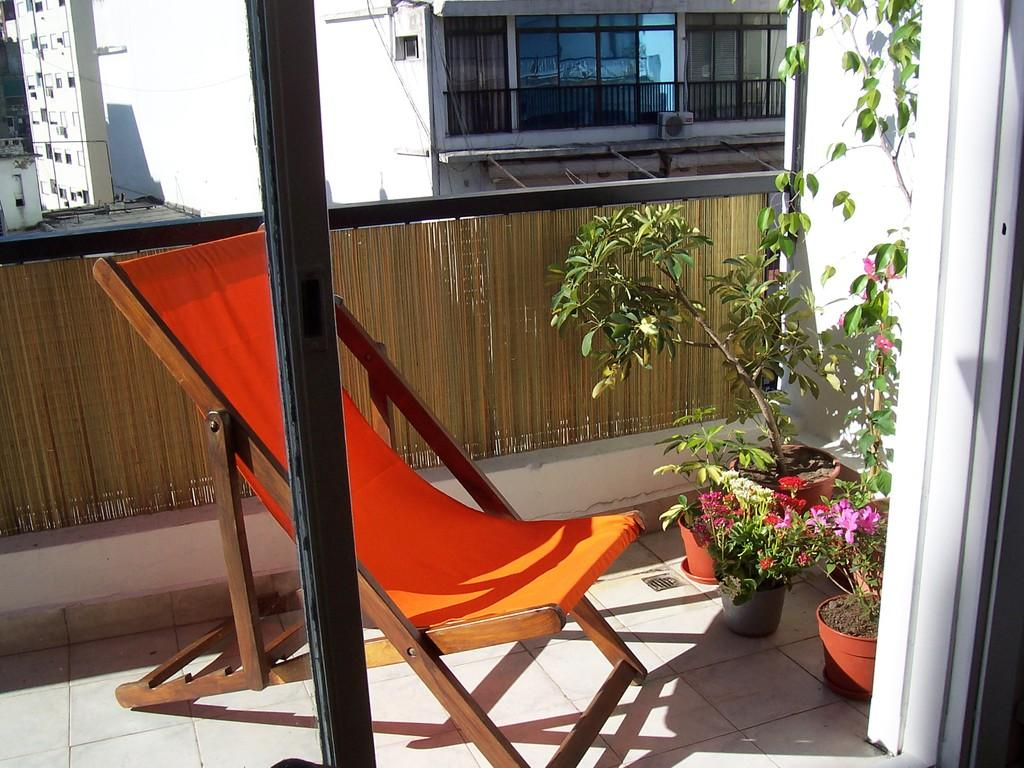What type of furniture is present in the image? There is a chair in the image. What is on the floor in the image? There is a pole on the floor in the image. What type of plants are near the chair? There are flower plants beside the chair. What type of barrier is present in the image? The image contains fencing. What can be seen in the background of the image? There are buildings visible outside. Can you tell me how many geese are standing on the floor in the image? There are no geese present in the image; the floor features a pole instead. Who can help the person in the image? The image does not depict a person, so it is not possible to determine who might help them. 